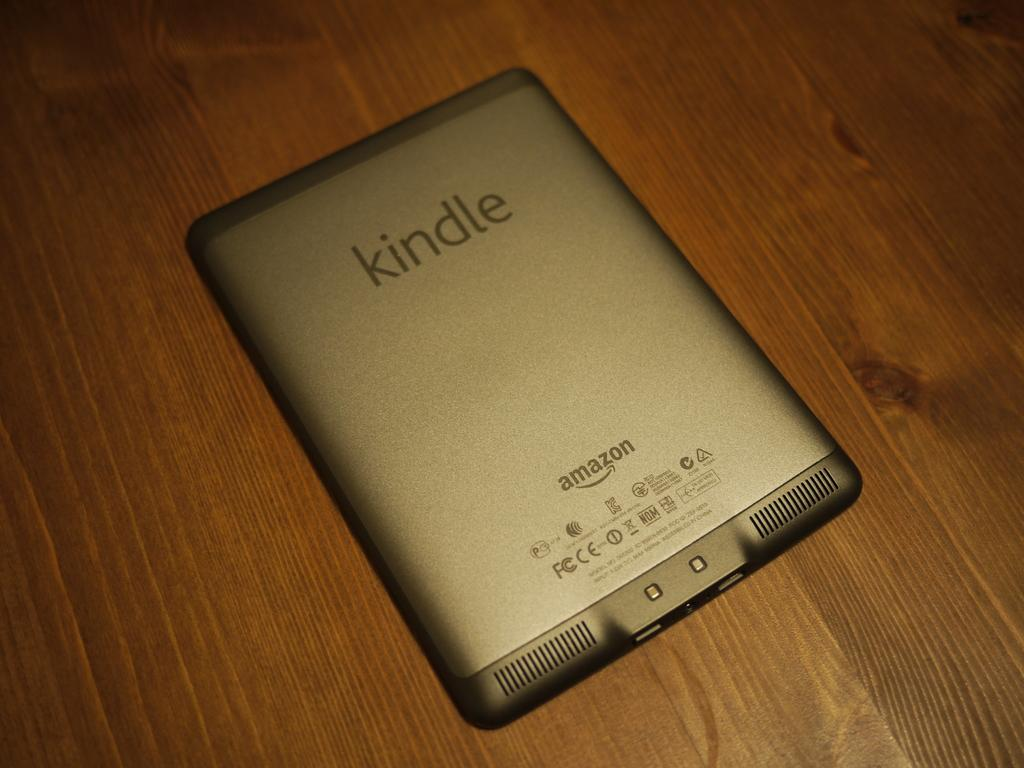<image>
Create a compact narrative representing the image presented. An Amazon Kindle is laid face down on a wood surface. 